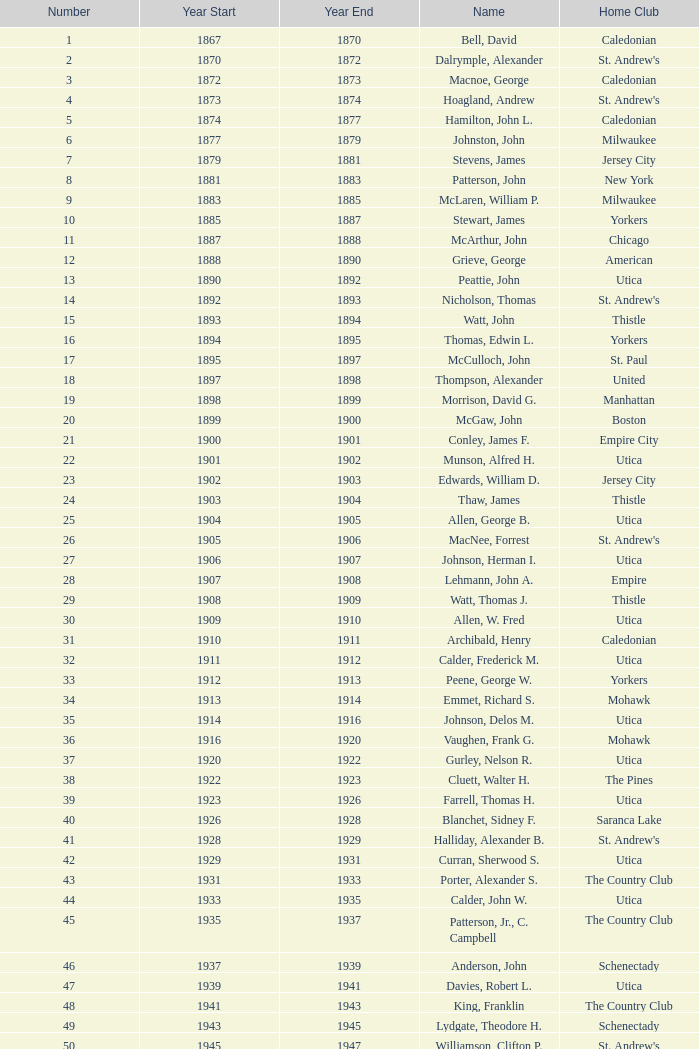What number is named after hill, lucius t.? 53.0. 